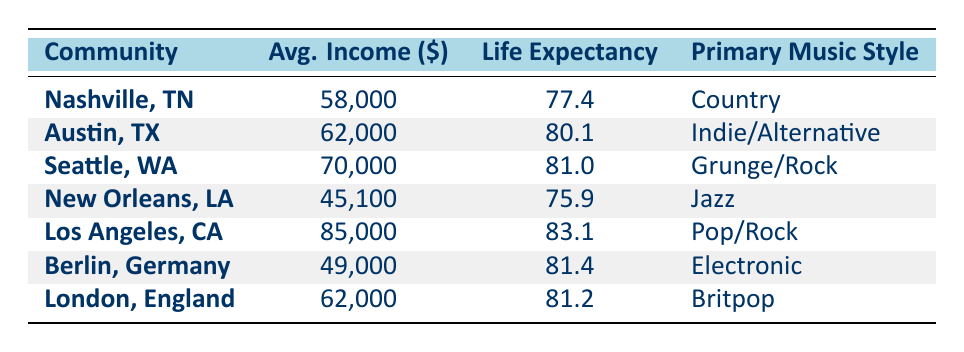What is the average income of Seattle, Washington? The table indicates that the average income for Seattle, Washington, is listed directly under the Average Income column, which states 70,000.
Answer: 70,000 Which community has the lowest life expectancy? By reviewing the Life Expectancy column, New Orleans, Louisiana, shows a value of 75.9, which is the lowest compared to other communities.
Answer: New Orleans, Louisiana What is the difference in life expectancy between Los Angeles and Nashville? From the table, Los Angeles has a life expectancy of 83.1 and Nashville has 77.4. The difference is calculated as 83.1 - 77.4 = 5.7.
Answer: 5.7 Is the average income in Berlin higher than that in New Orleans? The average income for Berlin is 49,000 while New Orleans has an average income of 45,100. Since 49,000 is greater than 45,100, the statement is true.
Answer: Yes What is the average life expectancy of all the communities combined? To find the average life expectancy, we sum all values from the Life Expectancy column: 77.4 + 80.1 + 81.0 + 75.9 + 83.1 + 81.4 + 81.2 = 480.1. There are 7 communities, so the average is 480.1 / 7 ≈ 68.59.
Answer: 68.59 What primary music style is associated with the highest average income? The table lists the average incomes alongside the primary music styles. Los Angeles has the highest income of 85,000 and is associated with the Pop/Rock genre.
Answer: Pop/Rock Which community has a higher life expectancy, Austin or London? Austin has a life expectancy of 80.1 while London has 81.2. Comparing the two shows that London has a higher life expectancy.
Answer: London What is the average income of communities with a primary music style of jazz? The only community with jazz as the primary music style is New Orleans, which has an average income of 45,100. Since there's only one community, the average income is simply that value.
Answer: 45,100 What is the total average income of all the communities in the table? Summing the average incomes: 58,000 + 62,000 + 70,000 + 45,100 + 85,000 + 49,000 + 62,000 = 431,100. The total income is 431,100 across all communities.
Answer: 431,100 